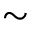Convert formula to latex. <formula><loc_0><loc_0><loc_500><loc_500>\sim</formula> 